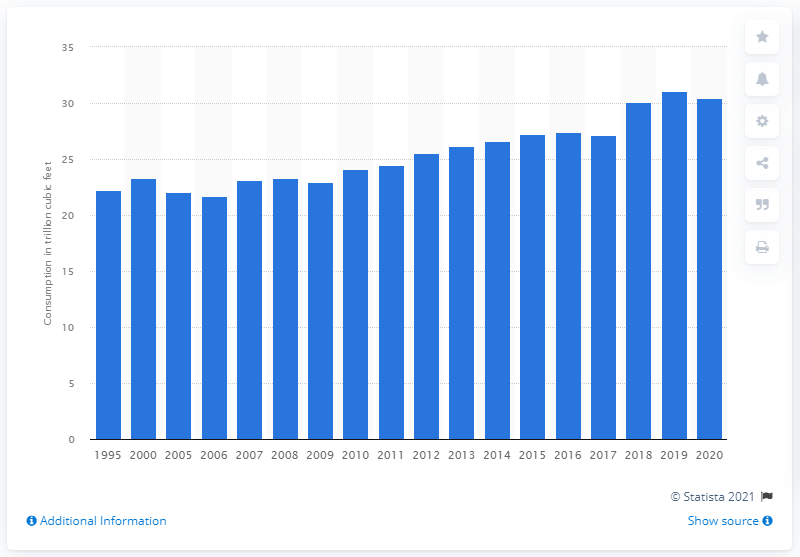Point out several critical features in this image. The highest amount of natural gas consumed in the United States in 2019 was 31.08 trillion cubic feet. 